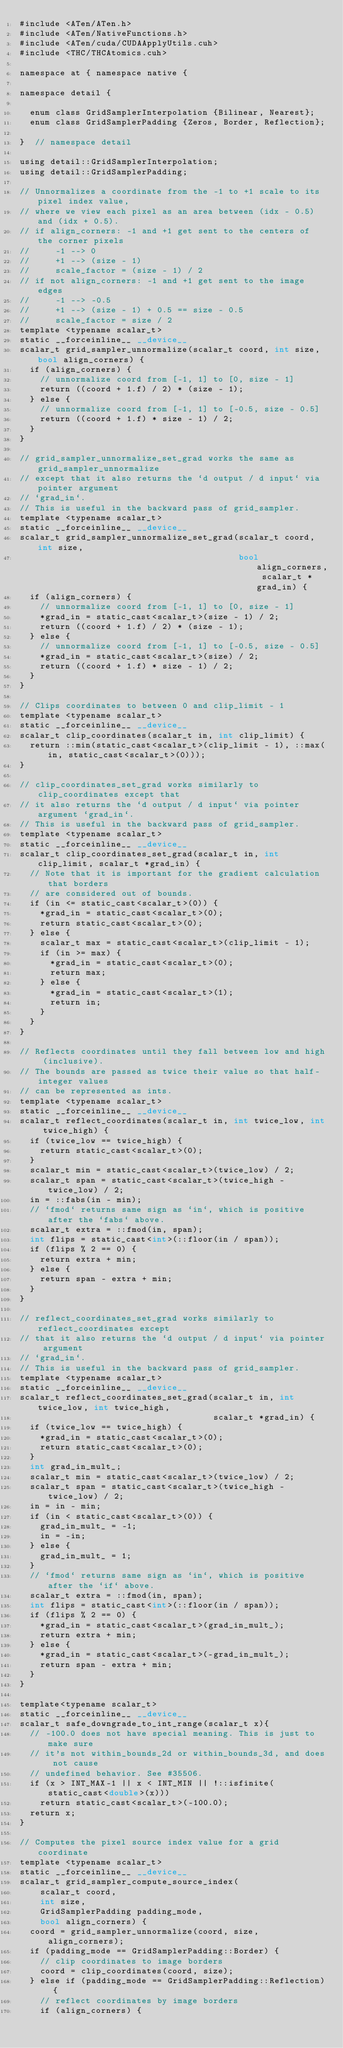<code> <loc_0><loc_0><loc_500><loc_500><_Cuda_>#include <ATen/ATen.h>
#include <ATen/NativeFunctions.h>
#include <ATen/cuda/CUDAApplyUtils.cuh>
#include <THC/THCAtomics.cuh>

namespace at { namespace native {

namespace detail {

  enum class GridSamplerInterpolation {Bilinear, Nearest};
  enum class GridSamplerPadding {Zeros, Border, Reflection};

}  // namespace detail

using detail::GridSamplerInterpolation;
using detail::GridSamplerPadding;

// Unnormalizes a coordinate from the -1 to +1 scale to its pixel index value,
// where we view each pixel as an area between (idx - 0.5) and (idx + 0.5).
// if align_corners: -1 and +1 get sent to the centers of the corner pixels
//     -1 --> 0
//     +1 --> (size - 1)
//     scale_factor = (size - 1) / 2
// if not align_corners: -1 and +1 get sent to the image edges
//     -1 --> -0.5
//     +1 --> (size - 1) + 0.5 == size - 0.5
//     scale_factor = size / 2
template <typename scalar_t>
static __forceinline__ __device__
scalar_t grid_sampler_unnormalize(scalar_t coord, int size, bool align_corners) {
  if (align_corners) {
    // unnormalize coord from [-1, 1] to [0, size - 1]
    return ((coord + 1.f) / 2) * (size - 1);
  } else {
    // unnormalize coord from [-1, 1] to [-0.5, size - 0.5]
    return ((coord + 1.f) * size - 1) / 2;
  }
}

// grid_sampler_unnormalize_set_grad works the same as grid_sampler_unnormalize
// except that it also returns the `d output / d input` via pointer argument
// `grad_in`.
// This is useful in the backward pass of grid_sampler.
template <typename scalar_t>
static __forceinline__ __device__
scalar_t grid_sampler_unnormalize_set_grad(scalar_t coord, int size,
                                           bool align_corners, scalar_t *grad_in) {
  if (align_corners) {
    // unnormalize coord from [-1, 1] to [0, size - 1]
    *grad_in = static_cast<scalar_t>(size - 1) / 2;
    return ((coord + 1.f) / 2) * (size - 1);
  } else {
    // unnormalize coord from [-1, 1] to [-0.5, size - 0.5]
    *grad_in = static_cast<scalar_t>(size) / 2;
    return ((coord + 1.f) * size - 1) / 2;
  }
}

// Clips coordinates to between 0 and clip_limit - 1
template <typename scalar_t>
static __forceinline__ __device__
scalar_t clip_coordinates(scalar_t in, int clip_limit) {
  return ::min(static_cast<scalar_t>(clip_limit - 1), ::max(in, static_cast<scalar_t>(0)));
}

// clip_coordinates_set_grad works similarly to clip_coordinates except that
// it also returns the `d output / d input` via pointer argument `grad_in`.
// This is useful in the backward pass of grid_sampler.
template <typename scalar_t>
static __forceinline__ __device__
scalar_t clip_coordinates_set_grad(scalar_t in, int clip_limit, scalar_t *grad_in) {
  // Note that it is important for the gradient calculation that borders
  // are considered out of bounds.
  if (in <= static_cast<scalar_t>(0)) {
    *grad_in = static_cast<scalar_t>(0);
    return static_cast<scalar_t>(0);
  } else {
    scalar_t max = static_cast<scalar_t>(clip_limit - 1);
    if (in >= max) {
      *grad_in = static_cast<scalar_t>(0);
      return max;
    } else {
      *grad_in = static_cast<scalar_t>(1);
      return in;
    }
  }
}

// Reflects coordinates until they fall between low and high (inclusive).
// The bounds are passed as twice their value so that half-integer values
// can be represented as ints.
template <typename scalar_t>
static __forceinline__ __device__
scalar_t reflect_coordinates(scalar_t in, int twice_low, int twice_high) {
  if (twice_low == twice_high) {
    return static_cast<scalar_t>(0);
  }
  scalar_t min = static_cast<scalar_t>(twice_low) / 2;
  scalar_t span = static_cast<scalar_t>(twice_high - twice_low) / 2;
  in = ::fabs(in - min);
  // `fmod` returns same sign as `in`, which is positive after the `fabs` above.
  scalar_t extra = ::fmod(in, span);
  int flips = static_cast<int>(::floor(in / span));
  if (flips % 2 == 0) {
    return extra + min;
  } else {
    return span - extra + min;
  }
}

// reflect_coordinates_set_grad works similarly to reflect_coordinates except
// that it also returns the `d output / d input` via pointer argument
// `grad_in`.
// This is useful in the backward pass of grid_sampler.
template <typename scalar_t>
static __forceinline__ __device__
scalar_t reflect_coordinates_set_grad(scalar_t in, int twice_low, int twice_high,
                                      scalar_t *grad_in) {
  if (twice_low == twice_high) {
    *grad_in = static_cast<scalar_t>(0);
    return static_cast<scalar_t>(0);
  }
  int grad_in_mult_;
  scalar_t min = static_cast<scalar_t>(twice_low) / 2;
  scalar_t span = static_cast<scalar_t>(twice_high - twice_low) / 2;
  in = in - min;
  if (in < static_cast<scalar_t>(0)) {
    grad_in_mult_ = -1;
    in = -in;
  } else {
    grad_in_mult_ = 1;
  }
  // `fmod` returns same sign as `in`, which is positive after the `if` above.
  scalar_t extra = ::fmod(in, span);
  int flips = static_cast<int>(::floor(in / span));
  if (flips % 2 == 0) {
    *grad_in = static_cast<scalar_t>(grad_in_mult_);
    return extra + min;
  } else {
    *grad_in = static_cast<scalar_t>(-grad_in_mult_);
    return span - extra + min;
  }
}

template<typename scalar_t> 
static __forceinline__ __device__ 
scalar_t safe_downgrade_to_int_range(scalar_t x){
  // -100.0 does not have special meaning. This is just to make sure 
  // it's not within_bounds_2d or within_bounds_3d, and does not cause 
  // undefined behavior. See #35506.  
  if (x > INT_MAX-1 || x < INT_MIN || !::isfinite(static_cast<double>(x))) 
    return static_cast<scalar_t>(-100.0); 
  return x;
}

// Computes the pixel source index value for a grid coordinate
template <typename scalar_t>
static __forceinline__ __device__
scalar_t grid_sampler_compute_source_index(
    scalar_t coord,
    int size,
    GridSamplerPadding padding_mode,
    bool align_corners) {
  coord = grid_sampler_unnormalize(coord, size, align_corners);
  if (padding_mode == GridSamplerPadding::Border) {
    // clip coordinates to image borders
    coord = clip_coordinates(coord, size);
  } else if (padding_mode == GridSamplerPadding::Reflection) {
    // reflect coordinates by image borders
    if (align_corners) {</code> 